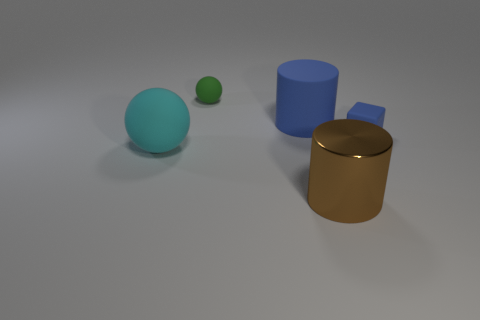Add 5 small green matte objects. How many objects exist? 10 Subtract all blocks. How many objects are left? 4 Add 4 cyan rubber spheres. How many cyan rubber spheres are left? 5 Add 2 big cyan shiny things. How many big cyan shiny things exist? 2 Subtract 0 gray spheres. How many objects are left? 5 Subtract all cyan balls. Subtract all purple cubes. How many balls are left? 1 Subtract all small green spheres. Subtract all tiny blocks. How many objects are left? 3 